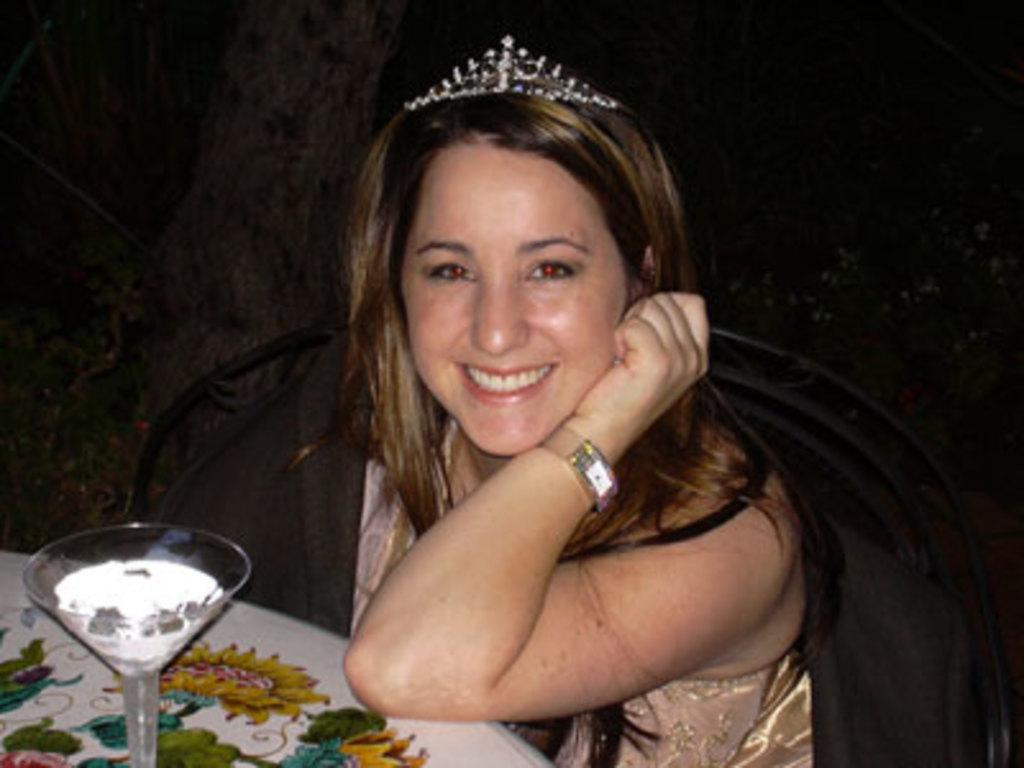Who is the main subject in the image? There is a lady in the image. What is the lady wearing on her head? The lady is wearing a crown. What accessory is the lady wearing on her wrist? The lady is wearing a watch. What is the lady's posture in the image? The lady is sitting. What object is in front of the lady? There is a table in front of the lady. What is on the table in the image? There is a glass on the table. How many boats are visible in the image? There are no boats present in the image. Who is the owner of the glass on the table? The image does not provide information about the ownership of the glass, so it cannot be determined. 